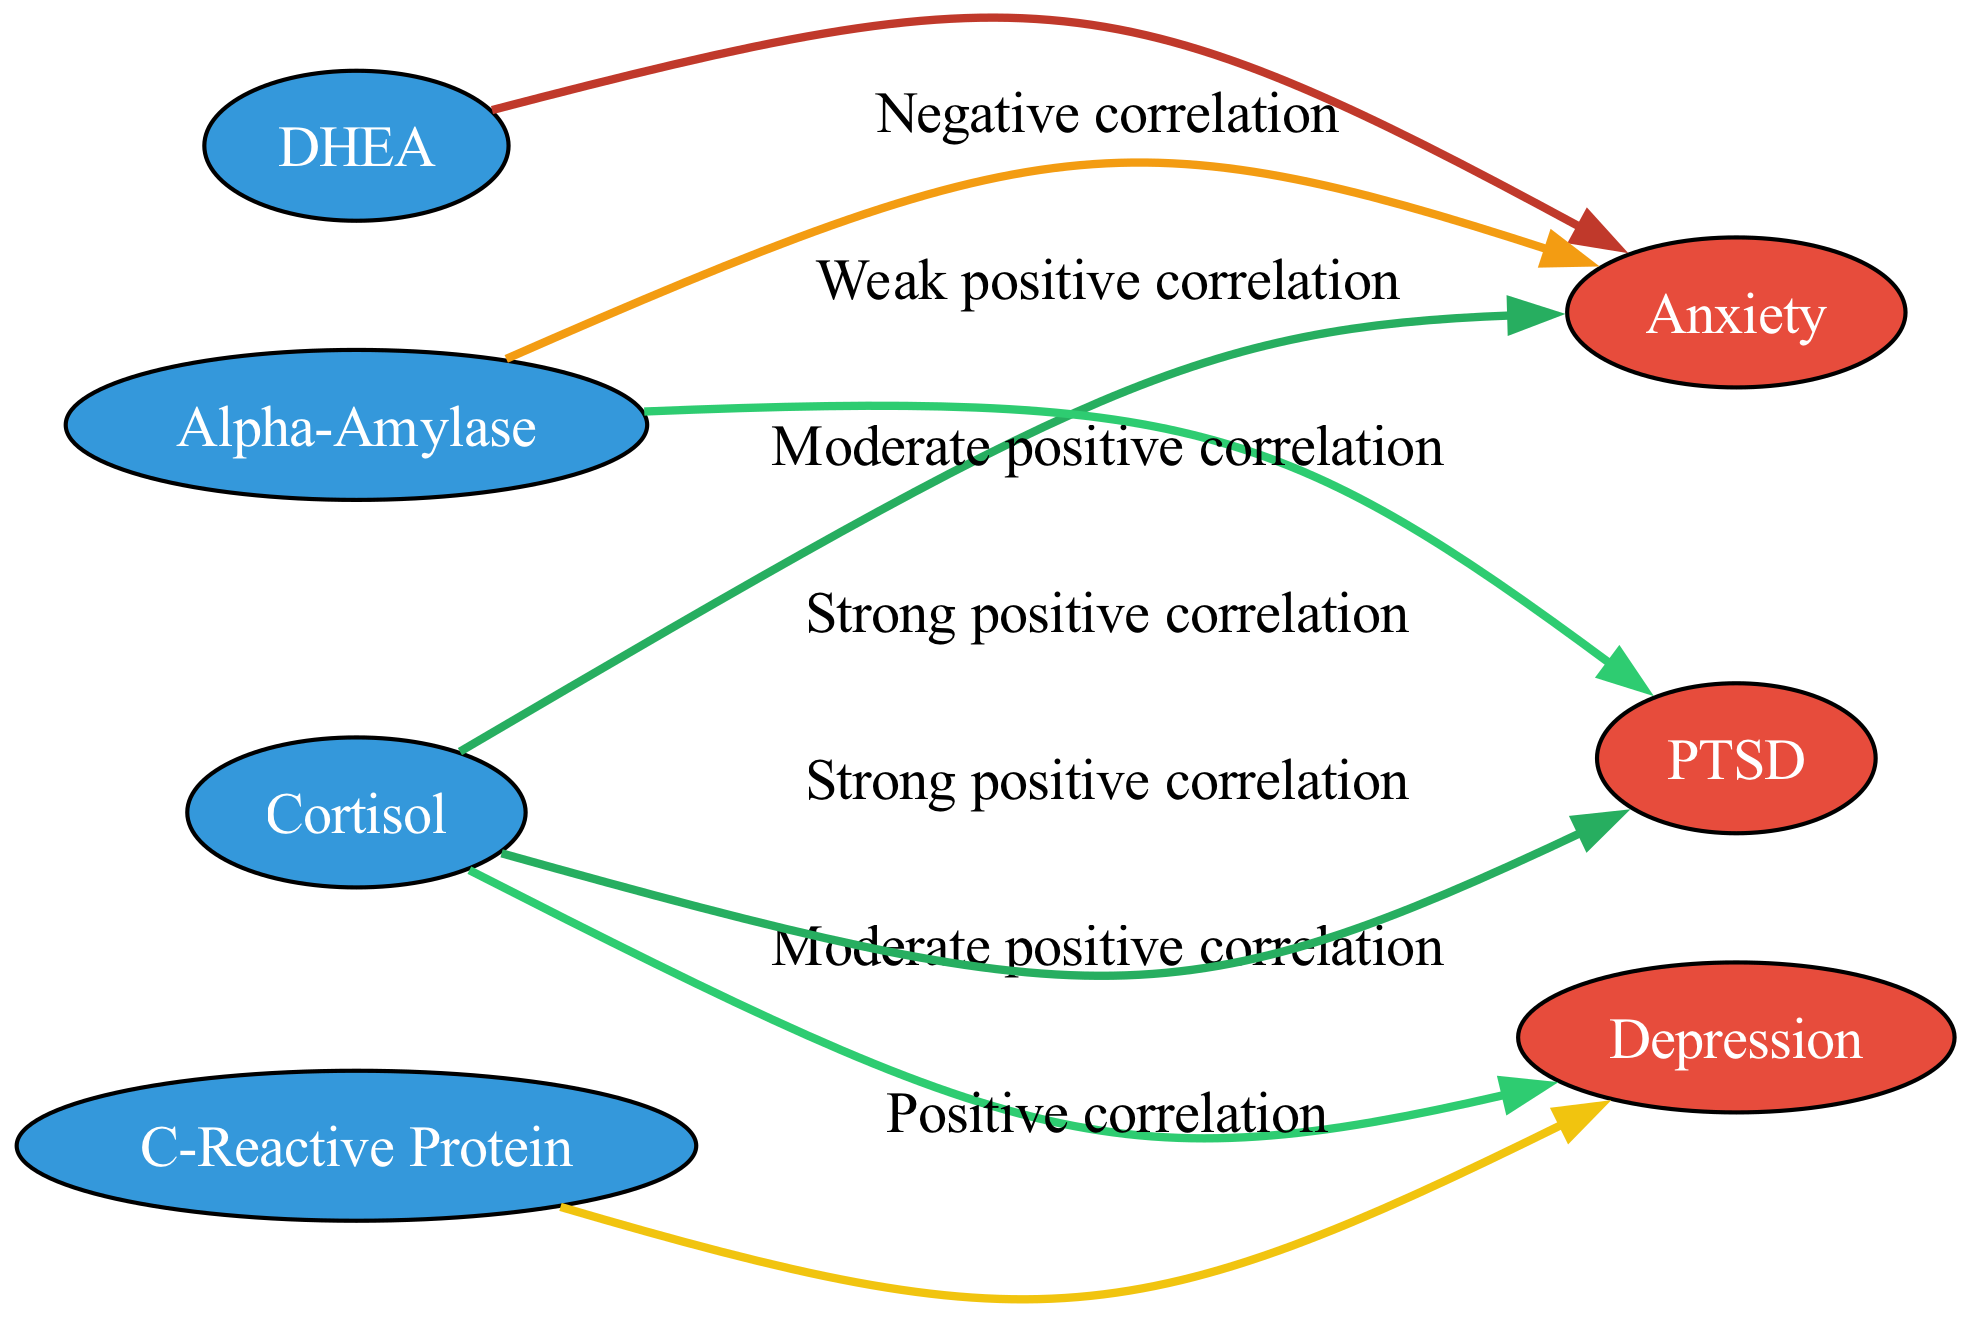What is the total number of nodes in the diagram? The diagram contains 7 nodes in total, representing 4 stress biomarkers and 3 mental health conditions. To find the total, we simply count each node listed in the diagram data.
Answer: 7 What is the correlation label between Cortisol and Anxiety? The correlation from the edge connecting Cortisol and Anxiety is described as a "Strong positive correlation." This is directly stated in the edge data connecting these two nodes.
Answer: Strong positive correlation How many mental health conditions are represented in the diagram? There are 3 mental health conditions represented: Anxiety, Depression, and PTSD. By reviewing the nodes, we can count the ones labeled as mental health.
Answer: 3 Which biomarker has a negative correlation with Anxiety? The biomarker with a negative correlation to Anxiety is DHEA, as indicated by the edge connecting these two nodes in the diagram, which specifically states the relationship as "Negative correlation."
Answer: DHEA What type of correlation does Alpha-Amylase have with PTSD? Alpha-Amylase is related to PTSD with a "Moderate positive correlation." This relationship is evidenced by the edge specifically labeled between these two nodes.
Answer: Moderate positive correlation Which biomarker has the strongest positive correlation with PTSD? Cortisol has the strongest positive correlation with PTSD, denoted by the edge labeled "Strong positive correlation." We can find this relationship by looking at the connections related to PTSD.
Answer: Cortisol What is the type of correlation between C-Reactive Protein and Depression? The correlation between C-Reactive Protein and Depression is described as a "Positive correlation." This is directly drawn from the edge connecting these two nodes in the diagram.
Answer: Positive correlation Which two stress biomarkers have weak positive correlations with Anxiety? The only biomarker that shows a weak positive correlation with Anxiety is Alpha-Amylase. This unique edge specifically states the correlation level.
Answer: Alpha-Amylase 